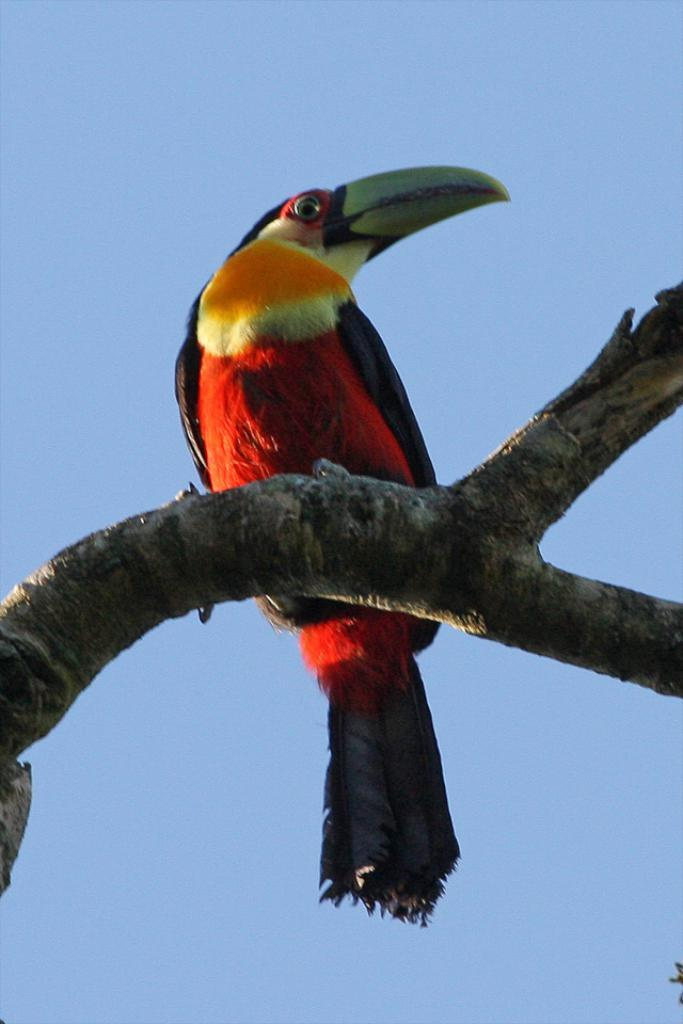What type of animal can be seen in the image? There is a bird in the image. Where is the bird located? The bird is on a branch. What can be seen in the background of the image? The sky is visible in the image. What color is the bead that the bird is holding in the image? There is no bead present in the image, and the bird is not holding anything. 